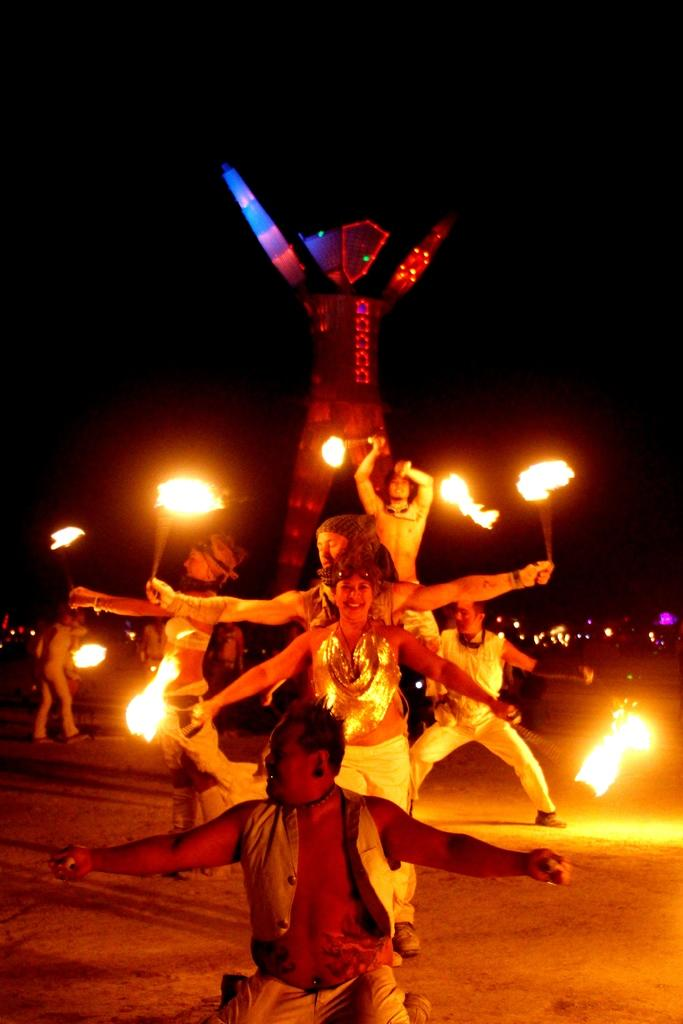What are the people in the image doing? The people in the image are dancing. What else can be seen in the image besides the people dancing? There is fire visible in the image, as well as a statue with lights. What is visible in the background of the image? The sky is visible in the image. How many bars of soap are being used by the dancers in the image? There is no soap present in the image; the people are dancing and there is fire and a statue with lights visible. 